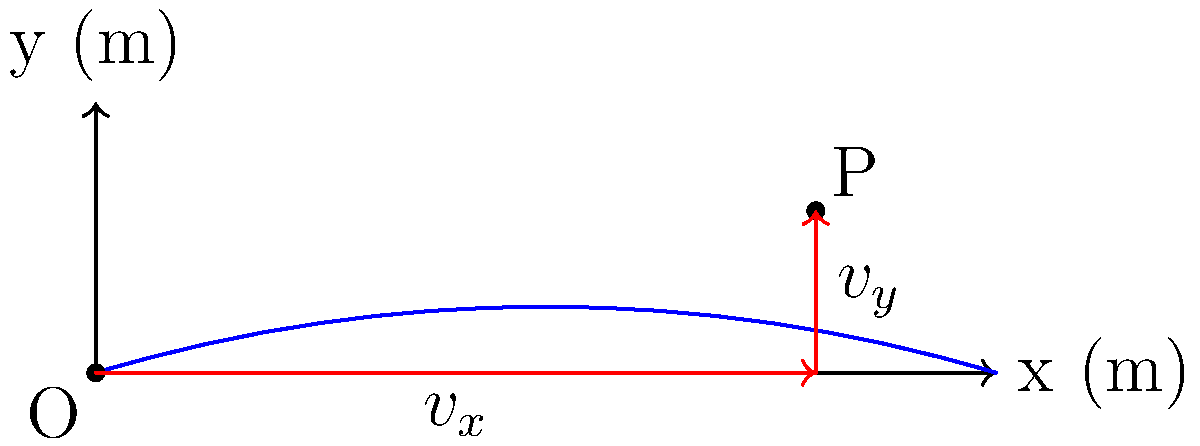In early firearms manufacturing, understanding projectile trajectories was crucial for improving accuracy. Consider a musket ball fired horizontally from point O, reaching its maximum height at point P, 80 meters downrange and 18 meters above the ground. If the ball's velocity at P is 50 m/s, determine the x and y components of the velocity vector at this point. To solve this problem, we'll follow these steps:

1) First, we need to understand that at the highest point of the trajectory (point P), the vertical component of velocity ($v_y$) is zero. This is because the projectile momentarily stops rising and begins to fall.

2) We're given that the total velocity at point P is 50 m/s. Since $v_y = 0$ at this point, the entire velocity must be in the horizontal direction.

3) Therefore, the x-component of velocity ($v_x$) at point P is equal to the total velocity:

   $v_x = 50$ m/s

4) To confirm, we can use the Pythagorean theorem:

   $v^2 = v_x^2 + v_y^2$
   $50^2 = 50^2 + 0^2$
   $2500 = 2500 + 0$

5) The y-component of velocity ($v_y$) at point P is:

   $v_y = 0$ m/s

Thus, the velocity vector at point P can be expressed as:

$\vec{v} = 50\hat{i} + 0\hat{j}$ m/s

Where $\hat{i}$ is the unit vector in the x-direction and $\hat{j}$ is the unit vector in the y-direction.
Answer: $v_x = 50$ m/s, $v_y = 0$ m/s 